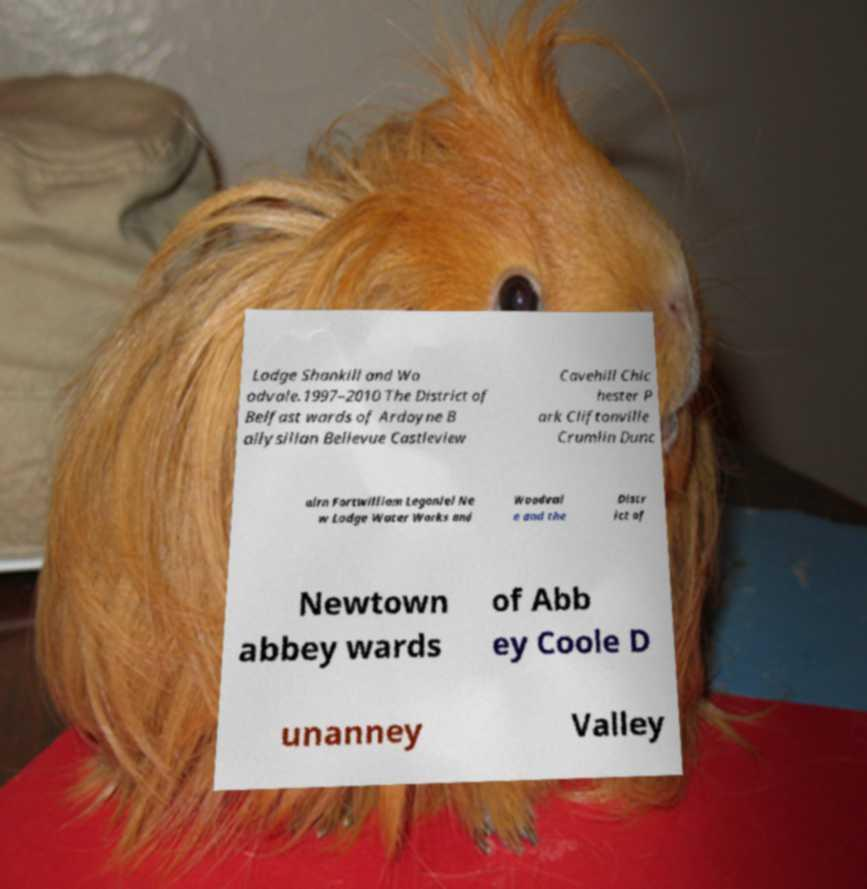Can you read and provide the text displayed in the image?This photo seems to have some interesting text. Can you extract and type it out for me? Lodge Shankill and Wo odvale.1997–2010 The District of Belfast wards of Ardoyne B allysillan Bellevue Castleview Cavehill Chic hester P ark Cliftonville Crumlin Dunc airn Fortwilliam Legoniel Ne w Lodge Water Works and Woodval e and the Distr ict of Newtown abbey wards of Abb ey Coole D unanney Valley 